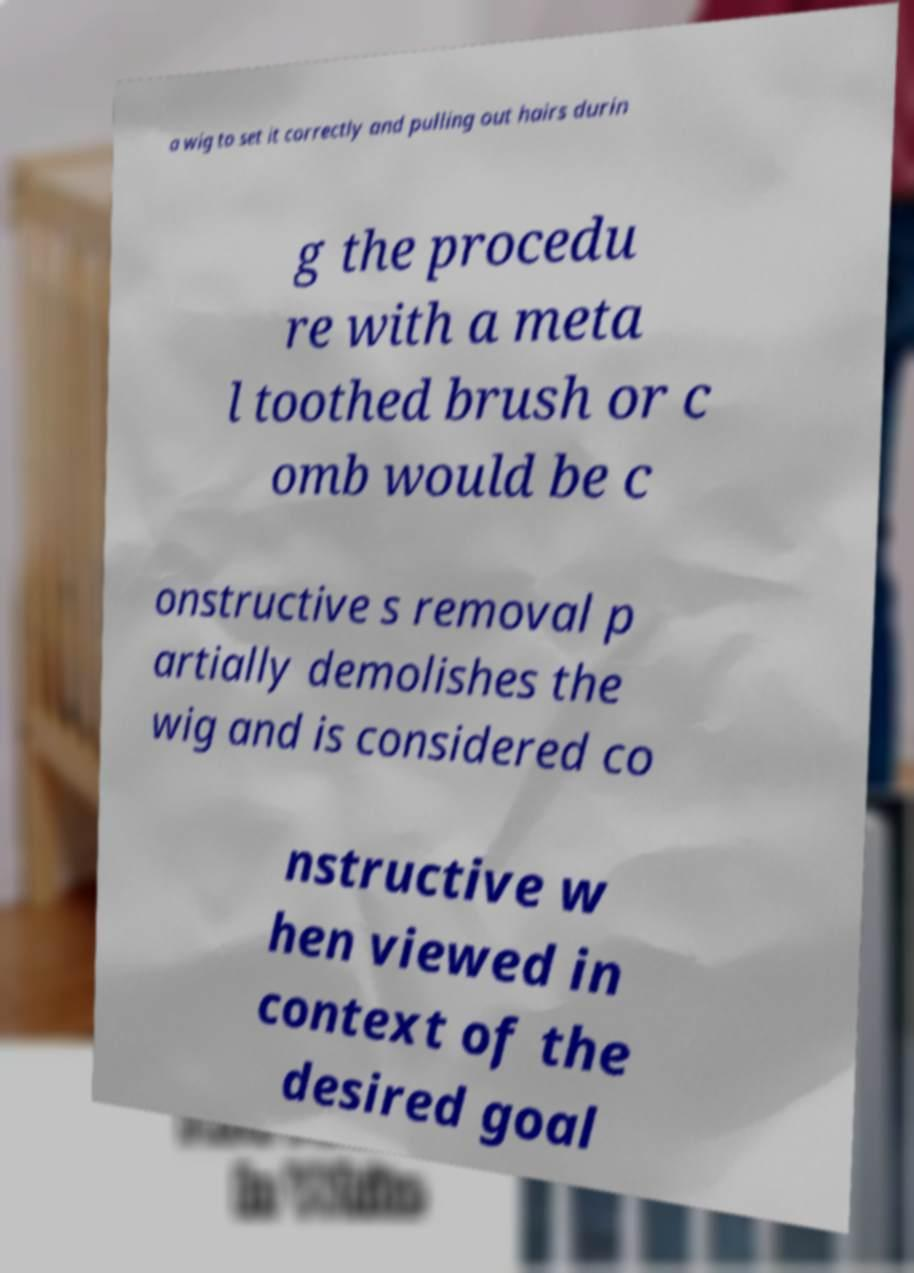Could you extract and type out the text from this image? a wig to set it correctly and pulling out hairs durin g the procedu re with a meta l toothed brush or c omb would be c onstructive s removal p artially demolishes the wig and is considered co nstructive w hen viewed in context of the desired goal 